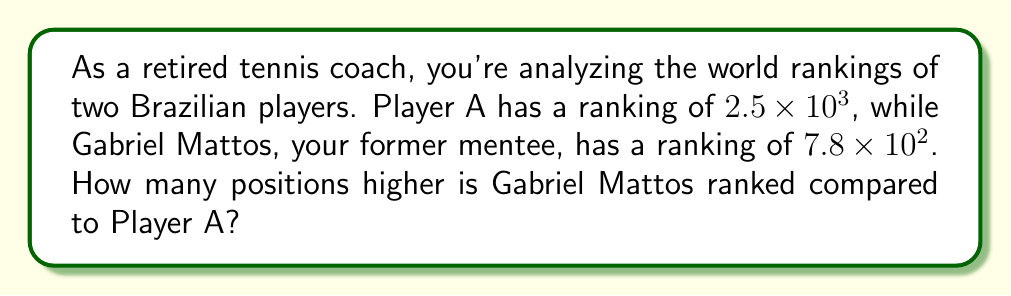Teach me how to tackle this problem. To solve this problem, we need to compare the two rankings in scientific notation:

1) Player A's ranking: $2.5 \times 10^3$
2) Gabriel Mattos' ranking: $7.8 \times 10^2$

First, we need to convert both numbers to the same exponent for easy comparison. Let's convert Gabriel's ranking to $10^3$:

$7.8 \times 10^2 = 0.78 \times 10^3$

Now we can directly compare:

$2.5 \times 10^3$ vs $0.78 \times 10^3$

Since a lower number indicates a better ranking in tennis, Gabriel Mattos has the better ranking.

To find how many positions higher Gabriel is ranked:

$2.5 \times 10^3 - 0.78 \times 10^3 = 1.72 \times 10^3$

Converting back to standard notation:

$1.72 \times 10^3 = 1,720$

Therefore, Gabriel Mattos is ranked 1,720 positions higher than Player A.
Answer: Gabriel Mattos is ranked 1,720 positions higher than Player A. 